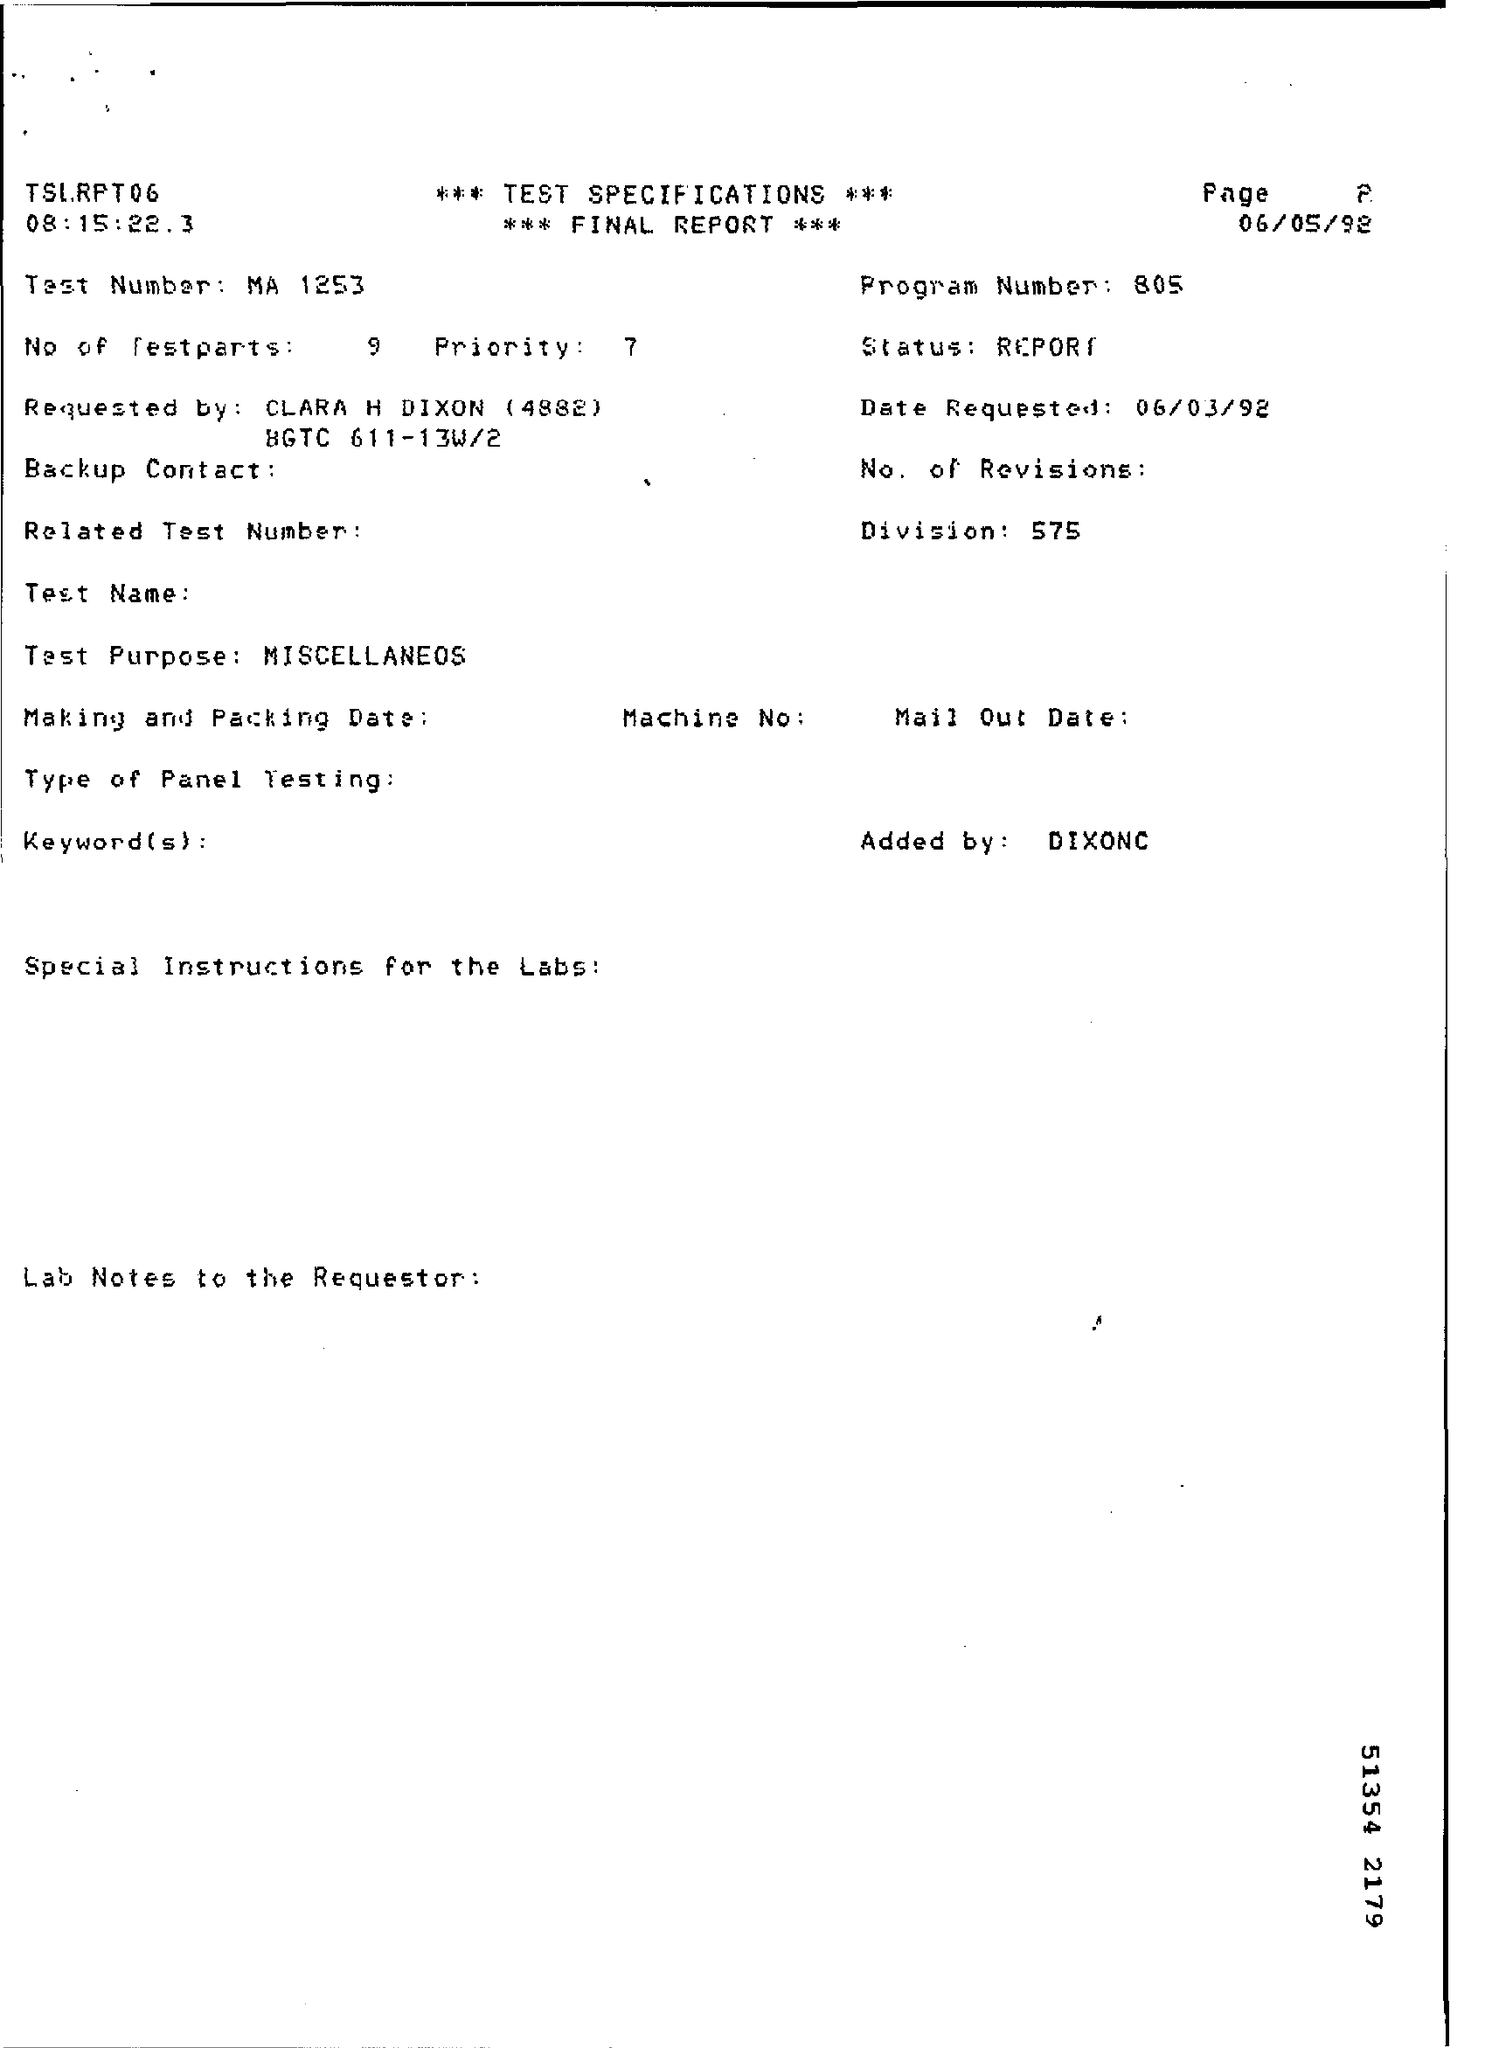What is the Division number?
Provide a succinct answer. 575. What is the Program Number?
Your answer should be compact. 805. 